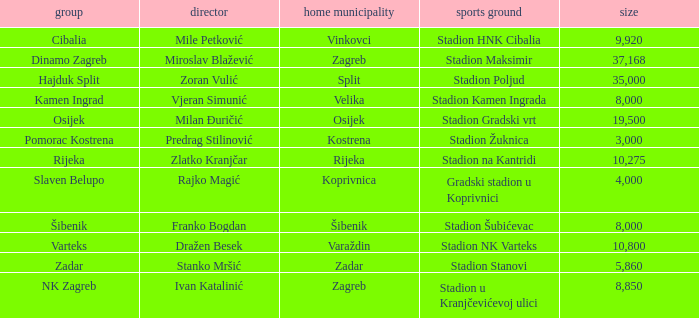What team has a home city of Velika? Kamen Ingrad. 